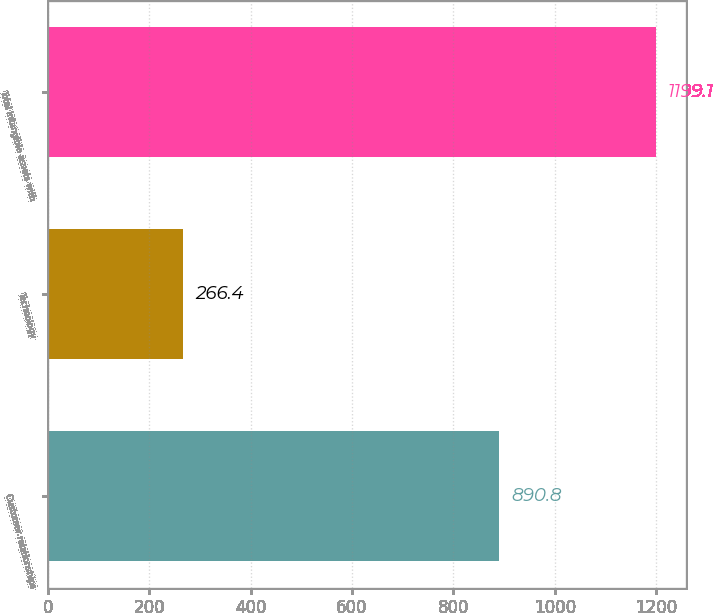Convert chart. <chart><loc_0><loc_0><loc_500><loc_500><bar_chart><fcel>Customer relationships<fcel>Technology<fcel>Total intangible assets with<nl><fcel>890.8<fcel>266.4<fcel>1199.1<nl></chart> 